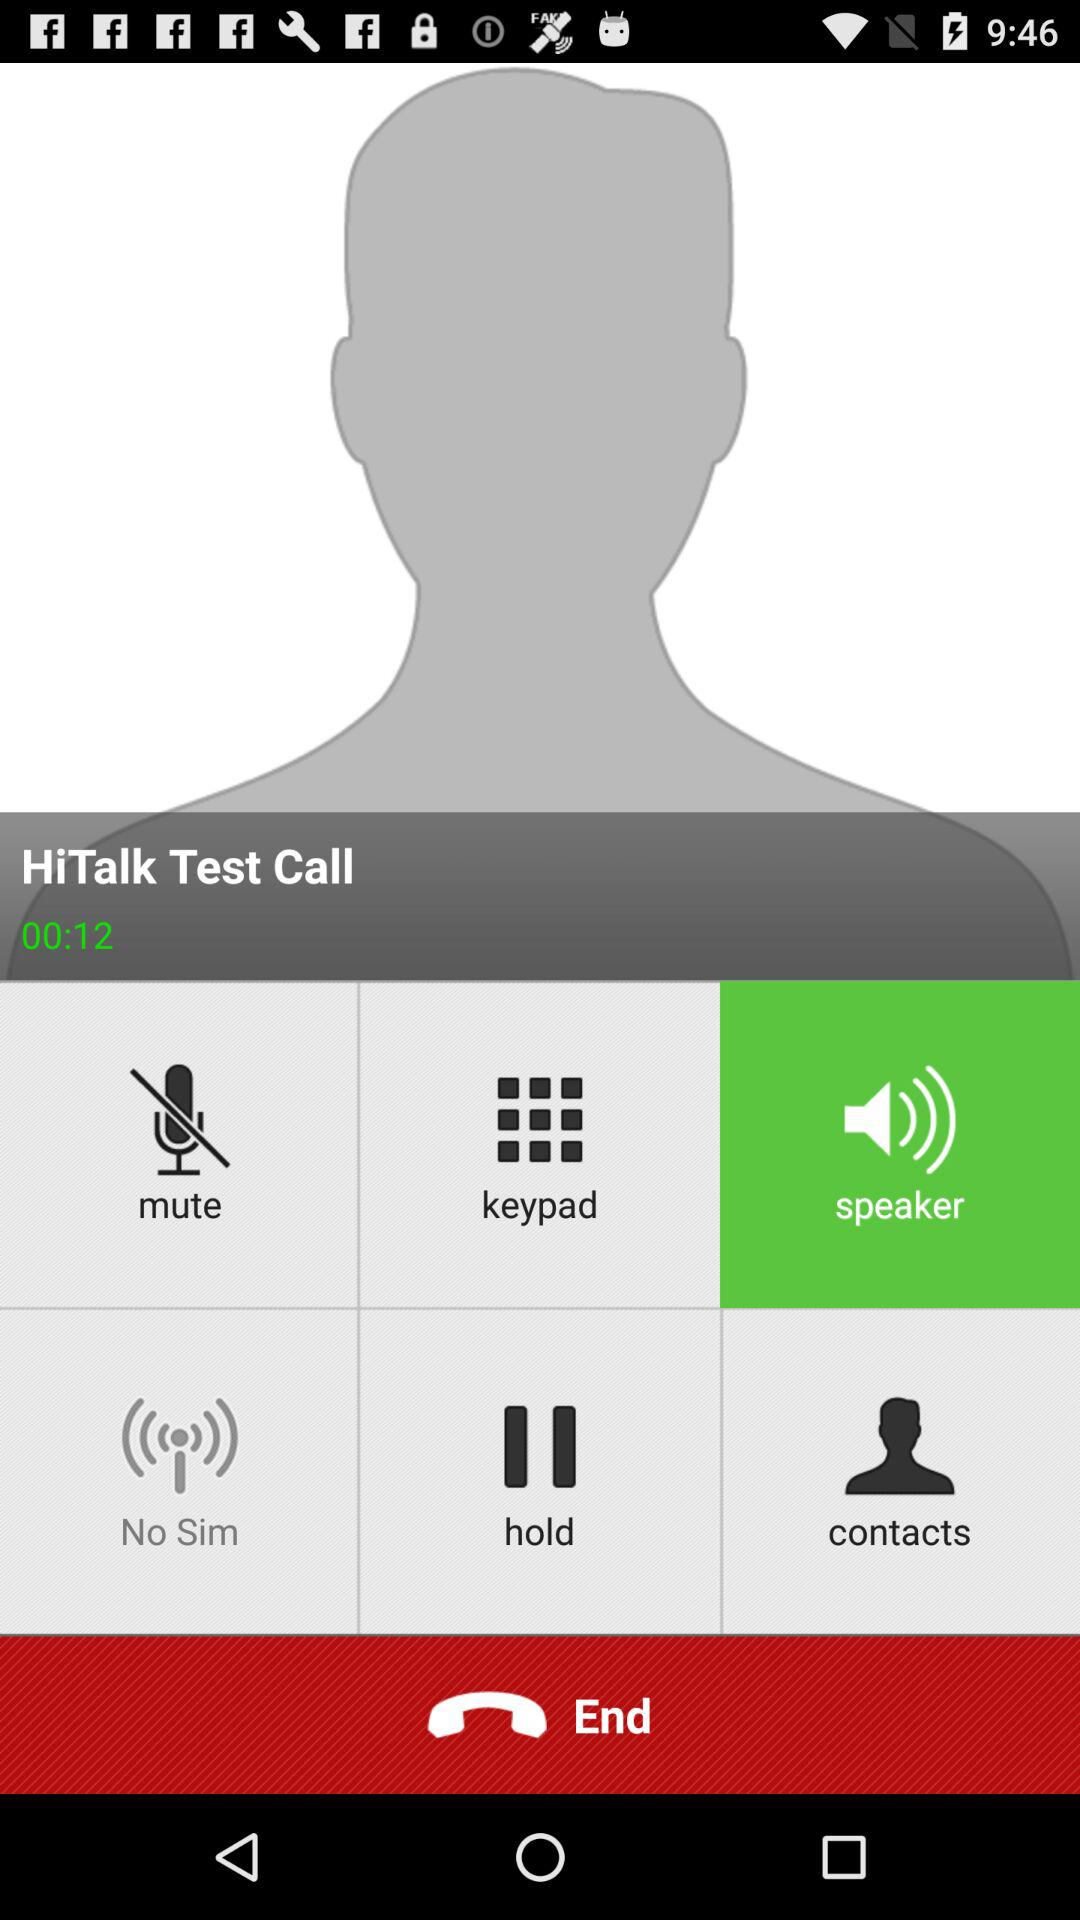What's the mentioned duration of the call? The duration is 12 seconds. 